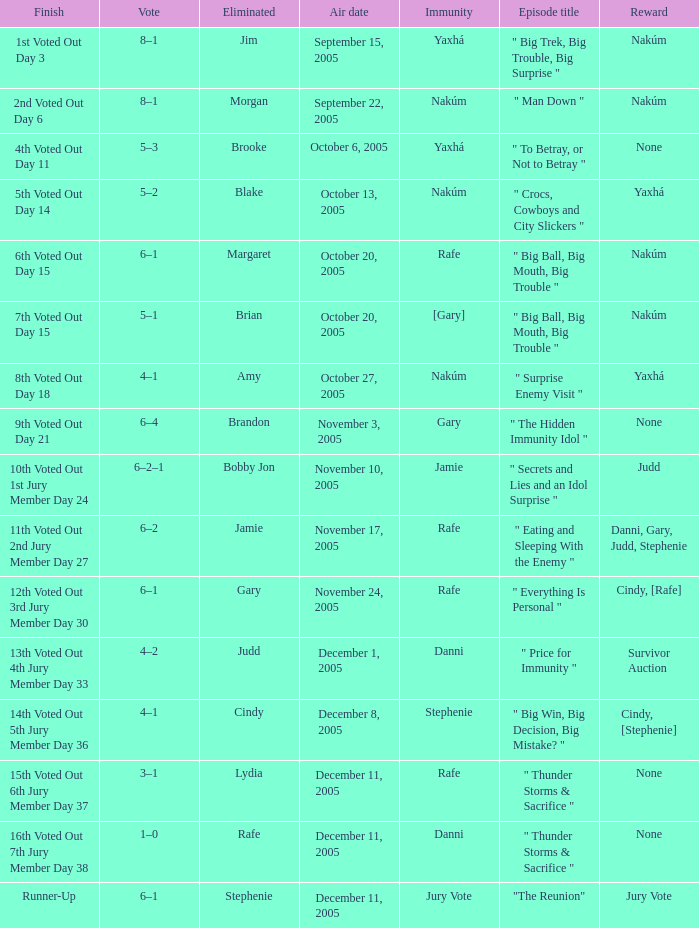How many air dates were there when Morgan was eliminated? 1.0. 